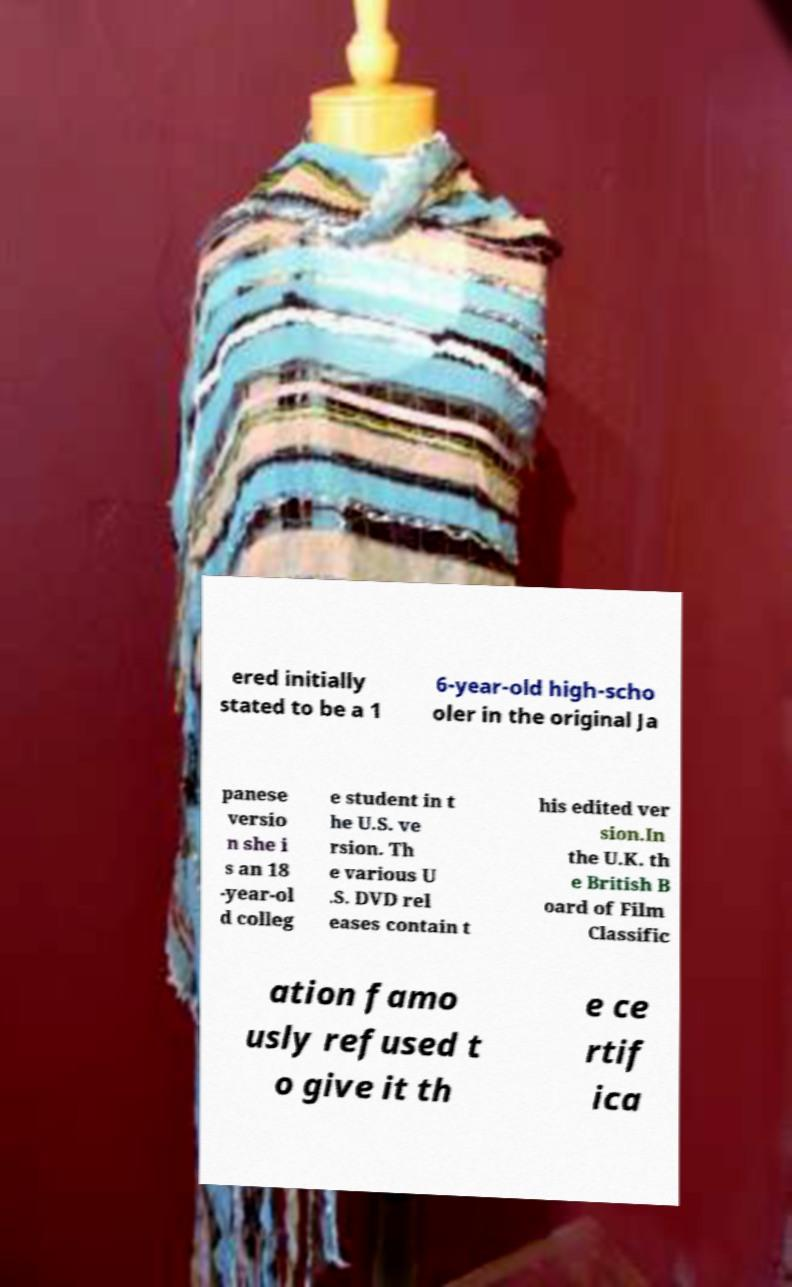Could you extract and type out the text from this image? ered initially stated to be a 1 6-year-old high-scho oler in the original Ja panese versio n she i s an 18 -year-ol d colleg e student in t he U.S. ve rsion. Th e various U .S. DVD rel eases contain t his edited ver sion.In the U.K. th e British B oard of Film Classific ation famo usly refused t o give it th e ce rtif ica 